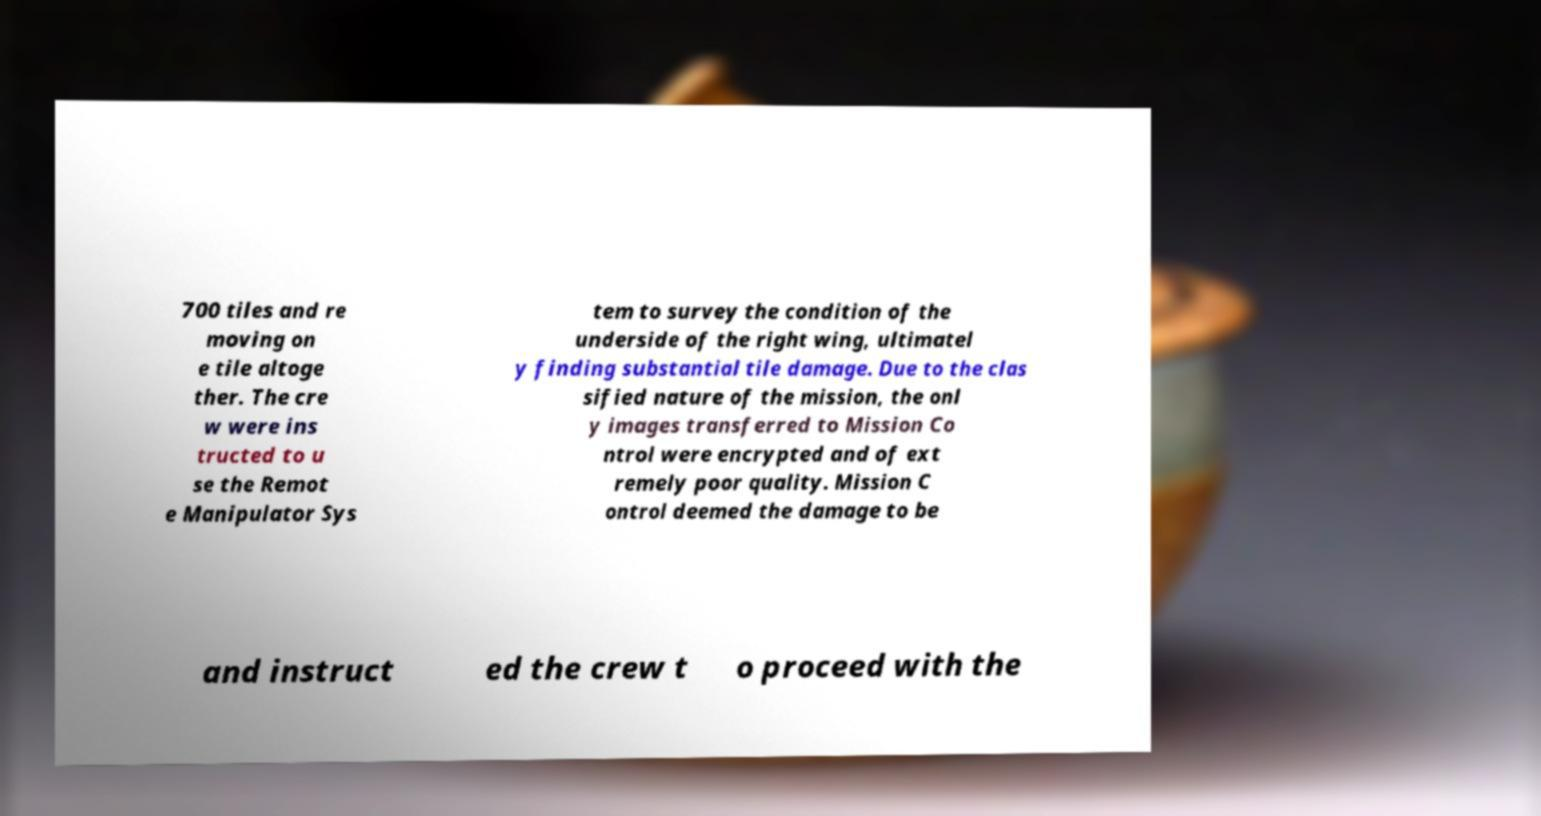Please identify and transcribe the text found in this image. 700 tiles and re moving on e tile altoge ther. The cre w were ins tructed to u se the Remot e Manipulator Sys tem to survey the condition of the underside of the right wing, ultimatel y finding substantial tile damage. Due to the clas sified nature of the mission, the onl y images transferred to Mission Co ntrol were encrypted and of ext remely poor quality. Mission C ontrol deemed the damage to be and instruct ed the crew t o proceed with the 